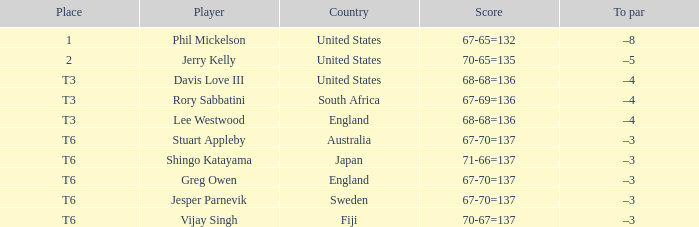Name the player for fiji Vijay Singh. 